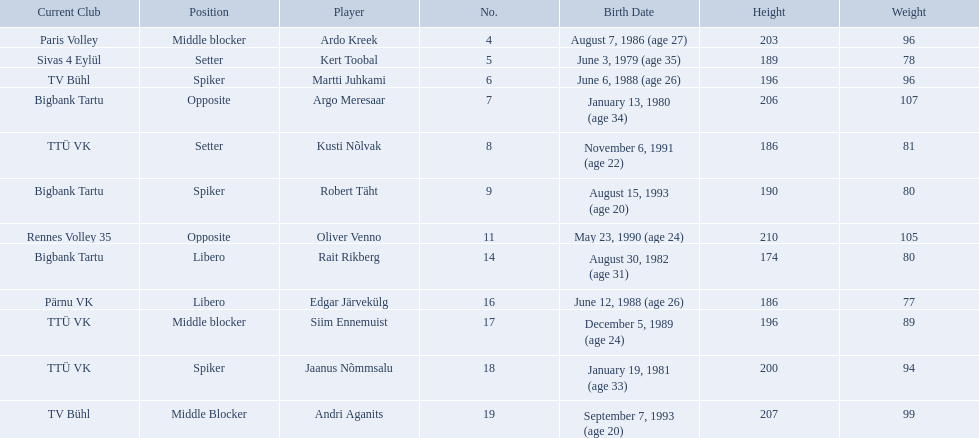Who are the players of the estonian men's national volleyball team? Ardo Kreek, Kert Toobal, Martti Juhkami, Argo Meresaar, Kusti Nõlvak, Robert Täht, Oliver Venno, Rait Rikberg, Edgar Järvekülg, Siim Ennemuist, Jaanus Nõmmsalu, Andri Aganits. Of these, which have a height over 200? Ardo Kreek, Argo Meresaar, Oliver Venno, Andri Aganits. Of the remaining, who is the tallest? Oliver Venno. 